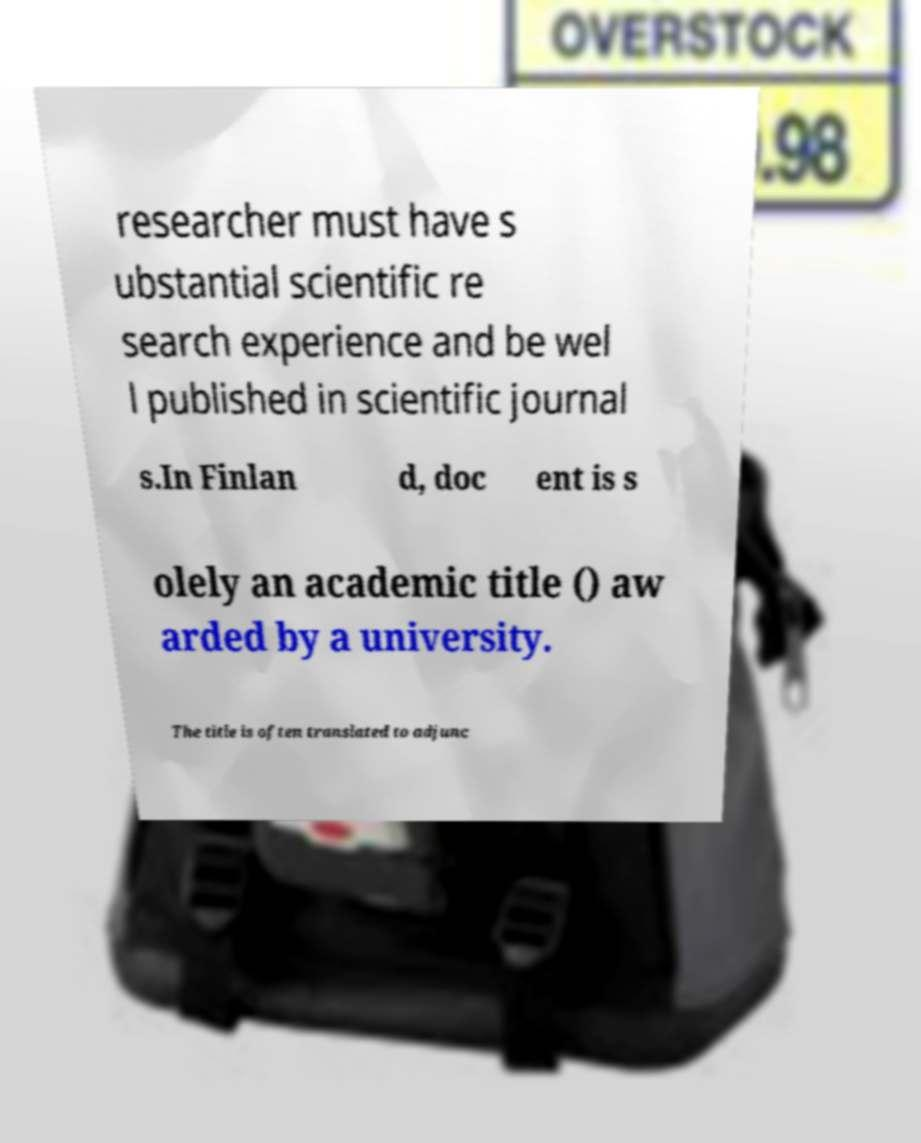Could you extract and type out the text from this image? researcher must have s ubstantial scientific re search experience and be wel l published in scientific journal s.In Finlan d, doc ent is s olely an academic title () aw arded by a university. The title is often translated to adjunc 